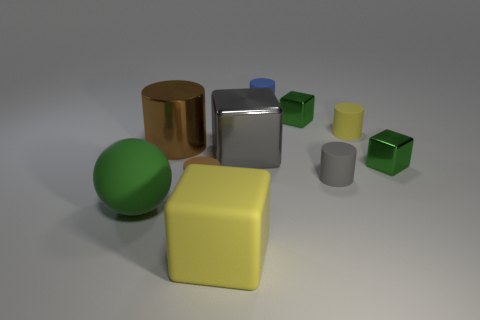Is there any other thing that is the same size as the gray shiny block?
Make the answer very short. Yes. There is a metallic cube that is to the left of the tiny blue cylinder; does it have the same color as the big shiny cylinder?
Provide a succinct answer. No. How many blocks are either cyan metal objects or large gray things?
Offer a very short reply. 1. What is the shape of the small green metallic thing that is on the right side of the tiny yellow matte cylinder?
Your answer should be very brief. Cube. The small cylinder that is on the left side of the block in front of the rubber cylinder that is left of the large yellow object is what color?
Ensure brevity in your answer.  Brown. Are the tiny brown cylinder and the large yellow object made of the same material?
Ensure brevity in your answer.  Yes. How many green objects are cylinders or large balls?
Your answer should be very brief. 1. What number of tiny cylinders are behind the big metallic cylinder?
Your response must be concise. 2. Is the number of yellow things greater than the number of big objects?
Ensure brevity in your answer.  No. The big matte thing that is left of the yellow object that is in front of the large sphere is what shape?
Keep it short and to the point. Sphere. 